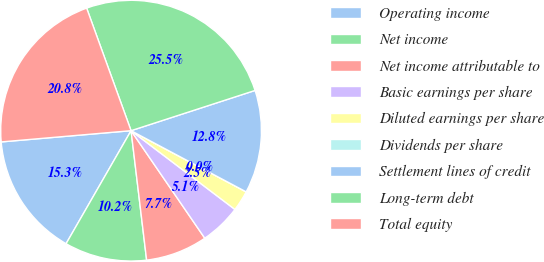<chart> <loc_0><loc_0><loc_500><loc_500><pie_chart><fcel>Operating income<fcel>Net income<fcel>Net income attributable to<fcel>Basic earnings per share<fcel>Diluted earnings per share<fcel>Dividends per share<fcel>Settlement lines of credit<fcel>Long-term debt<fcel>Total equity<nl><fcel>15.32%<fcel>10.21%<fcel>7.66%<fcel>5.11%<fcel>2.55%<fcel>0.0%<fcel>12.77%<fcel>25.54%<fcel>20.84%<nl></chart> 